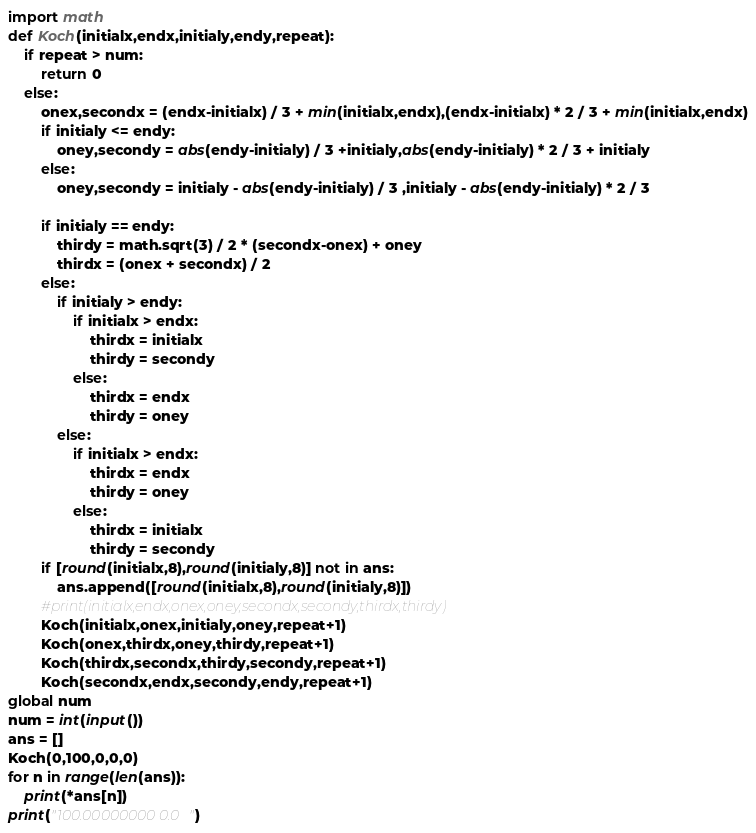Convert code to text. <code><loc_0><loc_0><loc_500><loc_500><_Python_>import math
def Koch(initialx,endx,initialy,endy,repeat):
    if repeat > num:
        return 0
    else:
        onex,secondx = (endx-initialx) / 3 + min(initialx,endx),(endx-initialx) * 2 / 3 + min(initialx,endx)
        if initialy <= endy:
            oney,secondy = abs(endy-initialy) / 3 +initialy,abs(endy-initialy) * 2 / 3 + initialy
        else:
            oney,secondy = initialy - abs(endy-initialy) / 3 ,initialy - abs(endy-initialy) * 2 / 3

        if initialy == endy:
            thirdy = math.sqrt(3) / 2 * (secondx-onex) + oney
            thirdx = (onex + secondx) / 2
        else:
            if initialy > endy:
                if initialx > endx:
                    thirdx = initialx
                    thirdy = secondy
                else:
                    thirdx = endx
                    thirdy = oney
            else:
                if initialx > endx:
                    thirdx = endx
                    thirdy = oney
                else:
                    thirdx = initialx
                    thirdy = secondy
        if [round(initialx,8),round(initialy,8)] not in ans:
            ans.append([round(initialx,8),round(initialy,8)])
        #print(initialx,endx,onex,oney,secondx,secondy,thirdx,thirdy)
        Koch(initialx,onex,initialy,oney,repeat+1)
        Koch(onex,thirdx,oney,thirdy,repeat+1)
        Koch(thirdx,secondx,thirdy,secondy,repeat+1)
        Koch(secondx,endx,secondy,endy,repeat+1)
global num
num = int(input())
ans = []
Koch(0,100,0,0,0)
for n in range(len(ans)):
    print(*ans[n])
print("100.00000000 0.0")</code> 